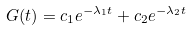Convert formula to latex. <formula><loc_0><loc_0><loc_500><loc_500>G ( t ) = c _ { 1 } e ^ { - \lambda _ { 1 } t } + c _ { 2 } e ^ { - \lambda _ { 2 } t }</formula> 